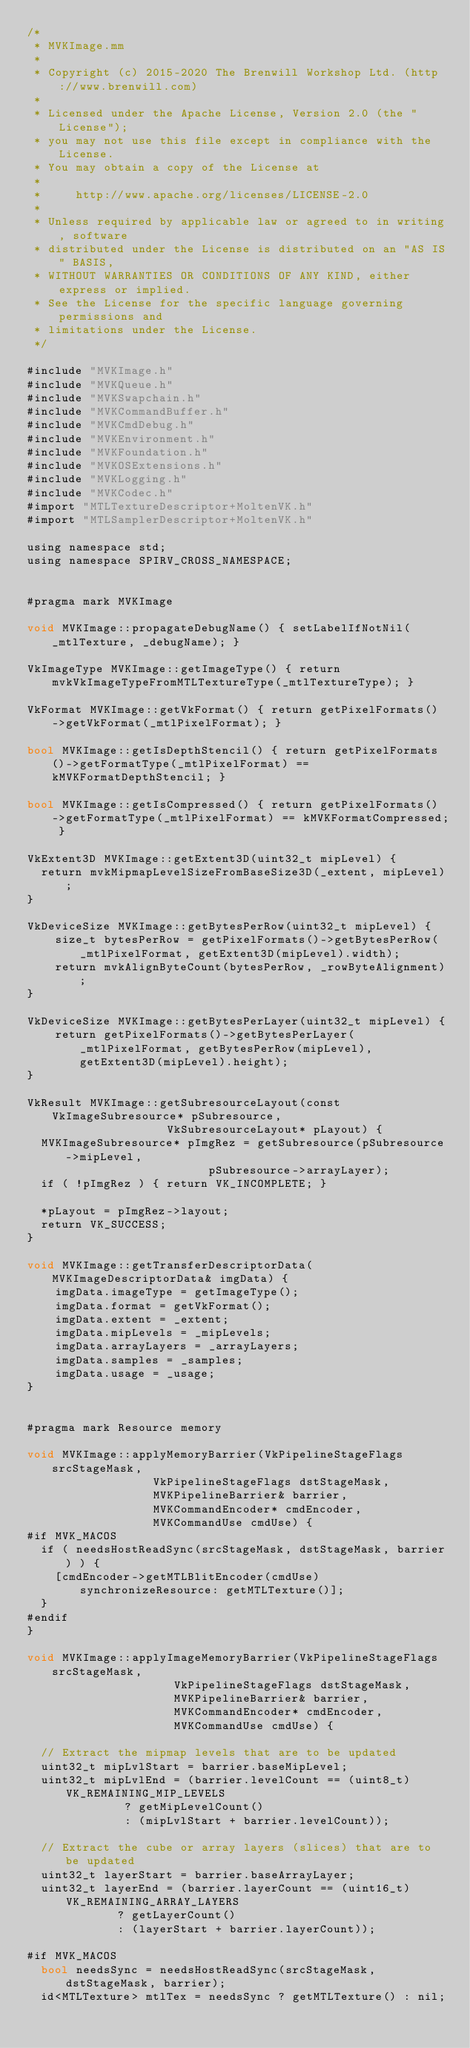Convert code to text. <code><loc_0><loc_0><loc_500><loc_500><_ObjectiveC_>/*
 * MVKImage.mm
 *
 * Copyright (c) 2015-2020 The Brenwill Workshop Ltd. (http://www.brenwill.com)
 *
 * Licensed under the Apache License, Version 2.0 (the "License");
 * you may not use this file except in compliance with the License.
 * You may obtain a copy of the License at
 * 
 *     http://www.apache.org/licenses/LICENSE-2.0
 * 
 * Unless required by applicable law or agreed to in writing, software
 * distributed under the License is distributed on an "AS IS" BASIS,
 * WITHOUT WARRANTIES OR CONDITIONS OF ANY KIND, either express or implied.
 * See the License for the specific language governing permissions and
 * limitations under the License.
 */

#include "MVKImage.h"
#include "MVKQueue.h"
#include "MVKSwapchain.h"
#include "MVKCommandBuffer.h"
#include "MVKCmdDebug.h"
#include "MVKEnvironment.h"
#include "MVKFoundation.h"
#include "MVKOSExtensions.h"
#include "MVKLogging.h"
#include "MVKCodec.h"
#import "MTLTextureDescriptor+MoltenVK.h"
#import "MTLSamplerDescriptor+MoltenVK.h"

using namespace std;
using namespace SPIRV_CROSS_NAMESPACE;


#pragma mark MVKImage

void MVKImage::propagateDebugName() { setLabelIfNotNil(_mtlTexture, _debugName); }

VkImageType MVKImage::getImageType() { return mvkVkImageTypeFromMTLTextureType(_mtlTextureType); }

VkFormat MVKImage::getVkFormat() { return getPixelFormats()->getVkFormat(_mtlPixelFormat); }

bool MVKImage::getIsDepthStencil() { return getPixelFormats()->getFormatType(_mtlPixelFormat) == kMVKFormatDepthStencil; }

bool MVKImage::getIsCompressed() { return getPixelFormats()->getFormatType(_mtlPixelFormat) == kMVKFormatCompressed; }

VkExtent3D MVKImage::getExtent3D(uint32_t mipLevel) {
	return mvkMipmapLevelSizeFromBaseSize3D(_extent, mipLevel);
}

VkDeviceSize MVKImage::getBytesPerRow(uint32_t mipLevel) {
    size_t bytesPerRow = getPixelFormats()->getBytesPerRow(_mtlPixelFormat, getExtent3D(mipLevel).width);
    return mvkAlignByteCount(bytesPerRow, _rowByteAlignment);
}

VkDeviceSize MVKImage::getBytesPerLayer(uint32_t mipLevel) {
    return getPixelFormats()->getBytesPerLayer(_mtlPixelFormat, getBytesPerRow(mipLevel), getExtent3D(mipLevel).height);
}

VkResult MVKImage::getSubresourceLayout(const VkImageSubresource* pSubresource,
										VkSubresourceLayout* pLayout) {
	MVKImageSubresource* pImgRez = getSubresource(pSubresource->mipLevel,
												  pSubresource->arrayLayer);
	if ( !pImgRez ) { return VK_INCOMPLETE; }

	*pLayout = pImgRez->layout;
	return VK_SUCCESS;
}

void MVKImage::getTransferDescriptorData(MVKImageDescriptorData& imgData) {
    imgData.imageType = getImageType();
    imgData.format = getVkFormat();
    imgData.extent = _extent;
    imgData.mipLevels = _mipLevels;
    imgData.arrayLayers = _arrayLayers;
    imgData.samples = _samples;
    imgData.usage = _usage;
}


#pragma mark Resource memory

void MVKImage::applyMemoryBarrier(VkPipelineStageFlags srcStageMask,
								  VkPipelineStageFlags dstStageMask,
								  MVKPipelineBarrier& barrier,
								  MVKCommandEncoder* cmdEncoder,
								  MVKCommandUse cmdUse) {
#if MVK_MACOS
	if ( needsHostReadSync(srcStageMask, dstStageMask, barrier) ) {
		[cmdEncoder->getMTLBlitEncoder(cmdUse) synchronizeResource: getMTLTexture()];
	}
#endif
}

void MVKImage::applyImageMemoryBarrier(VkPipelineStageFlags srcStageMask,
									   VkPipelineStageFlags dstStageMask,
									   MVKPipelineBarrier& barrier,
									   MVKCommandEncoder* cmdEncoder,
									   MVKCommandUse cmdUse) {

	// Extract the mipmap levels that are to be updated
	uint32_t mipLvlStart = barrier.baseMipLevel;
	uint32_t mipLvlEnd = (barrier.levelCount == (uint8_t)VK_REMAINING_MIP_LEVELS
						  ? getMipLevelCount()
						  : (mipLvlStart + barrier.levelCount));

	// Extract the cube or array layers (slices) that are to be updated
	uint32_t layerStart = barrier.baseArrayLayer;
	uint32_t layerEnd = (barrier.layerCount == (uint16_t)VK_REMAINING_ARRAY_LAYERS
						 ? getLayerCount()
						 : (layerStart + barrier.layerCount));

#if MVK_MACOS
	bool needsSync = needsHostReadSync(srcStageMask, dstStageMask, barrier);
	id<MTLTexture> mtlTex = needsSync ? getMTLTexture() : nil;</code> 